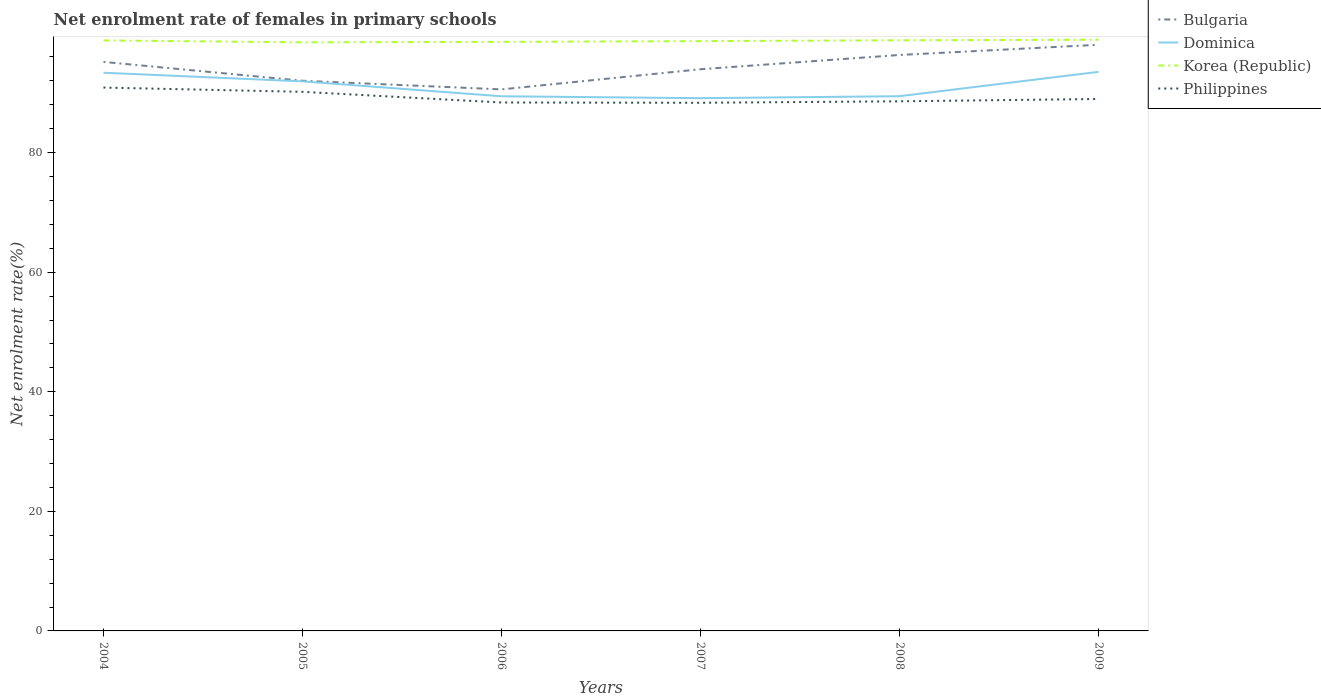Does the line corresponding to Philippines intersect with the line corresponding to Dominica?
Your answer should be compact. No. Is the number of lines equal to the number of legend labels?
Your answer should be very brief. Yes. Across all years, what is the maximum net enrolment rate of females in primary schools in Dominica?
Your answer should be very brief. 89.1. In which year was the net enrolment rate of females in primary schools in Bulgaria maximum?
Provide a short and direct response. 2006. What is the total net enrolment rate of females in primary schools in Philippines in the graph?
Ensure brevity in your answer.  -0.39. What is the difference between the highest and the second highest net enrolment rate of females in primary schools in Korea (Republic)?
Provide a short and direct response. 0.43. What is the difference between the highest and the lowest net enrolment rate of females in primary schools in Philippines?
Provide a short and direct response. 2. How many lines are there?
Ensure brevity in your answer.  4. Does the graph contain any zero values?
Your answer should be compact. No. How many legend labels are there?
Make the answer very short. 4. What is the title of the graph?
Provide a succinct answer. Net enrolment rate of females in primary schools. What is the label or title of the Y-axis?
Your answer should be compact. Net enrolment rate(%). What is the Net enrolment rate(%) in Bulgaria in 2004?
Your answer should be compact. 95.17. What is the Net enrolment rate(%) in Dominica in 2004?
Make the answer very short. 93.36. What is the Net enrolment rate(%) of Korea (Republic) in 2004?
Your answer should be compact. 98.76. What is the Net enrolment rate(%) in Philippines in 2004?
Offer a very short reply. 90.88. What is the Net enrolment rate(%) in Bulgaria in 2005?
Give a very brief answer. 92.02. What is the Net enrolment rate(%) of Dominica in 2005?
Your response must be concise. 91.91. What is the Net enrolment rate(%) of Korea (Republic) in 2005?
Offer a terse response. 98.45. What is the Net enrolment rate(%) in Philippines in 2005?
Ensure brevity in your answer.  90.16. What is the Net enrolment rate(%) of Bulgaria in 2006?
Provide a short and direct response. 90.57. What is the Net enrolment rate(%) in Dominica in 2006?
Make the answer very short. 89.42. What is the Net enrolment rate(%) of Korea (Republic) in 2006?
Give a very brief answer. 98.52. What is the Net enrolment rate(%) of Philippines in 2006?
Provide a succinct answer. 88.38. What is the Net enrolment rate(%) in Bulgaria in 2007?
Keep it short and to the point. 93.94. What is the Net enrolment rate(%) of Dominica in 2007?
Keep it short and to the point. 89.1. What is the Net enrolment rate(%) in Korea (Republic) in 2007?
Give a very brief answer. 98.64. What is the Net enrolment rate(%) in Philippines in 2007?
Your answer should be compact. 88.33. What is the Net enrolment rate(%) of Bulgaria in 2008?
Offer a very short reply. 96.33. What is the Net enrolment rate(%) of Dominica in 2008?
Your answer should be very brief. 89.43. What is the Net enrolment rate(%) of Korea (Republic) in 2008?
Your answer should be compact. 98.79. What is the Net enrolment rate(%) in Philippines in 2008?
Your response must be concise. 88.58. What is the Net enrolment rate(%) in Bulgaria in 2009?
Give a very brief answer. 98.04. What is the Net enrolment rate(%) of Dominica in 2009?
Offer a very short reply. 93.5. What is the Net enrolment rate(%) in Korea (Republic) in 2009?
Offer a terse response. 98.88. What is the Net enrolment rate(%) in Philippines in 2009?
Offer a terse response. 88.97. Across all years, what is the maximum Net enrolment rate(%) of Bulgaria?
Provide a succinct answer. 98.04. Across all years, what is the maximum Net enrolment rate(%) of Dominica?
Offer a very short reply. 93.5. Across all years, what is the maximum Net enrolment rate(%) in Korea (Republic)?
Provide a short and direct response. 98.88. Across all years, what is the maximum Net enrolment rate(%) of Philippines?
Offer a very short reply. 90.88. Across all years, what is the minimum Net enrolment rate(%) in Bulgaria?
Keep it short and to the point. 90.57. Across all years, what is the minimum Net enrolment rate(%) in Dominica?
Provide a succinct answer. 89.1. Across all years, what is the minimum Net enrolment rate(%) of Korea (Republic)?
Offer a very short reply. 98.45. Across all years, what is the minimum Net enrolment rate(%) in Philippines?
Your answer should be compact. 88.33. What is the total Net enrolment rate(%) in Bulgaria in the graph?
Give a very brief answer. 566.06. What is the total Net enrolment rate(%) of Dominica in the graph?
Offer a very short reply. 546.73. What is the total Net enrolment rate(%) of Korea (Republic) in the graph?
Give a very brief answer. 592.03. What is the total Net enrolment rate(%) in Philippines in the graph?
Make the answer very short. 535.3. What is the difference between the Net enrolment rate(%) in Bulgaria in 2004 and that in 2005?
Your answer should be very brief. 3.15. What is the difference between the Net enrolment rate(%) in Dominica in 2004 and that in 2005?
Your answer should be very brief. 1.45. What is the difference between the Net enrolment rate(%) in Korea (Republic) in 2004 and that in 2005?
Give a very brief answer. 0.32. What is the difference between the Net enrolment rate(%) of Philippines in 2004 and that in 2005?
Your response must be concise. 0.71. What is the difference between the Net enrolment rate(%) of Bulgaria in 2004 and that in 2006?
Your answer should be compact. 4.6. What is the difference between the Net enrolment rate(%) of Dominica in 2004 and that in 2006?
Give a very brief answer. 3.94. What is the difference between the Net enrolment rate(%) in Korea (Republic) in 2004 and that in 2006?
Your response must be concise. 0.24. What is the difference between the Net enrolment rate(%) in Philippines in 2004 and that in 2006?
Offer a very short reply. 2.5. What is the difference between the Net enrolment rate(%) in Bulgaria in 2004 and that in 2007?
Give a very brief answer. 1.23. What is the difference between the Net enrolment rate(%) in Dominica in 2004 and that in 2007?
Offer a terse response. 4.26. What is the difference between the Net enrolment rate(%) of Korea (Republic) in 2004 and that in 2007?
Provide a succinct answer. 0.12. What is the difference between the Net enrolment rate(%) in Philippines in 2004 and that in 2007?
Keep it short and to the point. 2.54. What is the difference between the Net enrolment rate(%) of Bulgaria in 2004 and that in 2008?
Ensure brevity in your answer.  -1.16. What is the difference between the Net enrolment rate(%) of Dominica in 2004 and that in 2008?
Make the answer very short. 3.93. What is the difference between the Net enrolment rate(%) of Korea (Republic) in 2004 and that in 2008?
Your answer should be very brief. -0.02. What is the difference between the Net enrolment rate(%) of Philippines in 2004 and that in 2008?
Keep it short and to the point. 2.3. What is the difference between the Net enrolment rate(%) of Bulgaria in 2004 and that in 2009?
Provide a succinct answer. -2.87. What is the difference between the Net enrolment rate(%) of Dominica in 2004 and that in 2009?
Your response must be concise. -0.14. What is the difference between the Net enrolment rate(%) in Korea (Republic) in 2004 and that in 2009?
Ensure brevity in your answer.  -0.12. What is the difference between the Net enrolment rate(%) in Philippines in 2004 and that in 2009?
Your answer should be very brief. 1.91. What is the difference between the Net enrolment rate(%) of Bulgaria in 2005 and that in 2006?
Provide a succinct answer. 1.45. What is the difference between the Net enrolment rate(%) of Dominica in 2005 and that in 2006?
Provide a short and direct response. 2.49. What is the difference between the Net enrolment rate(%) of Korea (Republic) in 2005 and that in 2006?
Ensure brevity in your answer.  -0.07. What is the difference between the Net enrolment rate(%) of Philippines in 2005 and that in 2006?
Make the answer very short. 1.78. What is the difference between the Net enrolment rate(%) in Bulgaria in 2005 and that in 2007?
Offer a very short reply. -1.93. What is the difference between the Net enrolment rate(%) in Dominica in 2005 and that in 2007?
Provide a short and direct response. 2.81. What is the difference between the Net enrolment rate(%) of Korea (Republic) in 2005 and that in 2007?
Offer a terse response. -0.2. What is the difference between the Net enrolment rate(%) of Philippines in 2005 and that in 2007?
Your answer should be very brief. 1.83. What is the difference between the Net enrolment rate(%) of Bulgaria in 2005 and that in 2008?
Offer a very short reply. -4.31. What is the difference between the Net enrolment rate(%) in Dominica in 2005 and that in 2008?
Make the answer very short. 2.48. What is the difference between the Net enrolment rate(%) in Korea (Republic) in 2005 and that in 2008?
Ensure brevity in your answer.  -0.34. What is the difference between the Net enrolment rate(%) of Philippines in 2005 and that in 2008?
Keep it short and to the point. 1.59. What is the difference between the Net enrolment rate(%) of Bulgaria in 2005 and that in 2009?
Your answer should be compact. -6.02. What is the difference between the Net enrolment rate(%) of Dominica in 2005 and that in 2009?
Provide a succinct answer. -1.59. What is the difference between the Net enrolment rate(%) of Korea (Republic) in 2005 and that in 2009?
Ensure brevity in your answer.  -0.43. What is the difference between the Net enrolment rate(%) in Philippines in 2005 and that in 2009?
Ensure brevity in your answer.  1.2. What is the difference between the Net enrolment rate(%) of Bulgaria in 2006 and that in 2007?
Offer a very short reply. -3.37. What is the difference between the Net enrolment rate(%) of Dominica in 2006 and that in 2007?
Provide a short and direct response. 0.32. What is the difference between the Net enrolment rate(%) in Korea (Republic) in 2006 and that in 2007?
Provide a succinct answer. -0.13. What is the difference between the Net enrolment rate(%) of Philippines in 2006 and that in 2007?
Your answer should be very brief. 0.05. What is the difference between the Net enrolment rate(%) in Bulgaria in 2006 and that in 2008?
Make the answer very short. -5.76. What is the difference between the Net enrolment rate(%) of Dominica in 2006 and that in 2008?
Provide a short and direct response. -0.01. What is the difference between the Net enrolment rate(%) in Korea (Republic) in 2006 and that in 2008?
Provide a short and direct response. -0.27. What is the difference between the Net enrolment rate(%) of Philippines in 2006 and that in 2008?
Your answer should be compact. -0.2. What is the difference between the Net enrolment rate(%) of Bulgaria in 2006 and that in 2009?
Offer a terse response. -7.46. What is the difference between the Net enrolment rate(%) of Dominica in 2006 and that in 2009?
Ensure brevity in your answer.  -4.08. What is the difference between the Net enrolment rate(%) of Korea (Republic) in 2006 and that in 2009?
Offer a very short reply. -0.36. What is the difference between the Net enrolment rate(%) in Philippines in 2006 and that in 2009?
Give a very brief answer. -0.59. What is the difference between the Net enrolment rate(%) of Bulgaria in 2007 and that in 2008?
Keep it short and to the point. -2.38. What is the difference between the Net enrolment rate(%) in Dominica in 2007 and that in 2008?
Ensure brevity in your answer.  -0.33. What is the difference between the Net enrolment rate(%) of Korea (Republic) in 2007 and that in 2008?
Your answer should be very brief. -0.14. What is the difference between the Net enrolment rate(%) in Philippines in 2007 and that in 2008?
Offer a terse response. -0.25. What is the difference between the Net enrolment rate(%) of Bulgaria in 2007 and that in 2009?
Your response must be concise. -4.09. What is the difference between the Net enrolment rate(%) of Dominica in 2007 and that in 2009?
Offer a terse response. -4.4. What is the difference between the Net enrolment rate(%) in Korea (Republic) in 2007 and that in 2009?
Offer a very short reply. -0.23. What is the difference between the Net enrolment rate(%) in Philippines in 2007 and that in 2009?
Give a very brief answer. -0.63. What is the difference between the Net enrolment rate(%) of Bulgaria in 2008 and that in 2009?
Offer a terse response. -1.71. What is the difference between the Net enrolment rate(%) of Dominica in 2008 and that in 2009?
Your answer should be compact. -4.07. What is the difference between the Net enrolment rate(%) of Korea (Republic) in 2008 and that in 2009?
Offer a terse response. -0.09. What is the difference between the Net enrolment rate(%) of Philippines in 2008 and that in 2009?
Provide a short and direct response. -0.39. What is the difference between the Net enrolment rate(%) of Bulgaria in 2004 and the Net enrolment rate(%) of Dominica in 2005?
Your response must be concise. 3.26. What is the difference between the Net enrolment rate(%) of Bulgaria in 2004 and the Net enrolment rate(%) of Korea (Republic) in 2005?
Give a very brief answer. -3.28. What is the difference between the Net enrolment rate(%) in Bulgaria in 2004 and the Net enrolment rate(%) in Philippines in 2005?
Your response must be concise. 5.01. What is the difference between the Net enrolment rate(%) of Dominica in 2004 and the Net enrolment rate(%) of Korea (Republic) in 2005?
Your answer should be very brief. -5.09. What is the difference between the Net enrolment rate(%) in Dominica in 2004 and the Net enrolment rate(%) in Philippines in 2005?
Offer a terse response. 3.2. What is the difference between the Net enrolment rate(%) of Korea (Republic) in 2004 and the Net enrolment rate(%) of Philippines in 2005?
Make the answer very short. 8.6. What is the difference between the Net enrolment rate(%) of Bulgaria in 2004 and the Net enrolment rate(%) of Dominica in 2006?
Keep it short and to the point. 5.75. What is the difference between the Net enrolment rate(%) of Bulgaria in 2004 and the Net enrolment rate(%) of Korea (Republic) in 2006?
Keep it short and to the point. -3.35. What is the difference between the Net enrolment rate(%) of Bulgaria in 2004 and the Net enrolment rate(%) of Philippines in 2006?
Provide a short and direct response. 6.79. What is the difference between the Net enrolment rate(%) of Dominica in 2004 and the Net enrolment rate(%) of Korea (Republic) in 2006?
Offer a terse response. -5.16. What is the difference between the Net enrolment rate(%) in Dominica in 2004 and the Net enrolment rate(%) in Philippines in 2006?
Provide a short and direct response. 4.98. What is the difference between the Net enrolment rate(%) of Korea (Republic) in 2004 and the Net enrolment rate(%) of Philippines in 2006?
Keep it short and to the point. 10.38. What is the difference between the Net enrolment rate(%) in Bulgaria in 2004 and the Net enrolment rate(%) in Dominica in 2007?
Keep it short and to the point. 6.07. What is the difference between the Net enrolment rate(%) of Bulgaria in 2004 and the Net enrolment rate(%) of Korea (Republic) in 2007?
Give a very brief answer. -3.47. What is the difference between the Net enrolment rate(%) of Bulgaria in 2004 and the Net enrolment rate(%) of Philippines in 2007?
Provide a succinct answer. 6.84. What is the difference between the Net enrolment rate(%) in Dominica in 2004 and the Net enrolment rate(%) in Korea (Republic) in 2007?
Provide a succinct answer. -5.28. What is the difference between the Net enrolment rate(%) of Dominica in 2004 and the Net enrolment rate(%) of Philippines in 2007?
Your response must be concise. 5.03. What is the difference between the Net enrolment rate(%) in Korea (Republic) in 2004 and the Net enrolment rate(%) in Philippines in 2007?
Provide a succinct answer. 10.43. What is the difference between the Net enrolment rate(%) of Bulgaria in 2004 and the Net enrolment rate(%) of Dominica in 2008?
Ensure brevity in your answer.  5.74. What is the difference between the Net enrolment rate(%) in Bulgaria in 2004 and the Net enrolment rate(%) in Korea (Republic) in 2008?
Keep it short and to the point. -3.62. What is the difference between the Net enrolment rate(%) of Bulgaria in 2004 and the Net enrolment rate(%) of Philippines in 2008?
Your response must be concise. 6.59. What is the difference between the Net enrolment rate(%) of Dominica in 2004 and the Net enrolment rate(%) of Korea (Republic) in 2008?
Offer a very short reply. -5.43. What is the difference between the Net enrolment rate(%) in Dominica in 2004 and the Net enrolment rate(%) in Philippines in 2008?
Your answer should be compact. 4.78. What is the difference between the Net enrolment rate(%) in Korea (Republic) in 2004 and the Net enrolment rate(%) in Philippines in 2008?
Your answer should be compact. 10.18. What is the difference between the Net enrolment rate(%) of Bulgaria in 2004 and the Net enrolment rate(%) of Dominica in 2009?
Offer a very short reply. 1.67. What is the difference between the Net enrolment rate(%) of Bulgaria in 2004 and the Net enrolment rate(%) of Korea (Republic) in 2009?
Your response must be concise. -3.71. What is the difference between the Net enrolment rate(%) of Bulgaria in 2004 and the Net enrolment rate(%) of Philippines in 2009?
Offer a very short reply. 6.2. What is the difference between the Net enrolment rate(%) of Dominica in 2004 and the Net enrolment rate(%) of Korea (Republic) in 2009?
Make the answer very short. -5.52. What is the difference between the Net enrolment rate(%) of Dominica in 2004 and the Net enrolment rate(%) of Philippines in 2009?
Your answer should be compact. 4.39. What is the difference between the Net enrolment rate(%) in Korea (Republic) in 2004 and the Net enrolment rate(%) in Philippines in 2009?
Your answer should be compact. 9.79. What is the difference between the Net enrolment rate(%) of Bulgaria in 2005 and the Net enrolment rate(%) of Dominica in 2006?
Give a very brief answer. 2.6. What is the difference between the Net enrolment rate(%) in Bulgaria in 2005 and the Net enrolment rate(%) in Korea (Republic) in 2006?
Provide a short and direct response. -6.5. What is the difference between the Net enrolment rate(%) of Bulgaria in 2005 and the Net enrolment rate(%) of Philippines in 2006?
Offer a very short reply. 3.64. What is the difference between the Net enrolment rate(%) of Dominica in 2005 and the Net enrolment rate(%) of Korea (Republic) in 2006?
Offer a very short reply. -6.61. What is the difference between the Net enrolment rate(%) of Dominica in 2005 and the Net enrolment rate(%) of Philippines in 2006?
Keep it short and to the point. 3.53. What is the difference between the Net enrolment rate(%) of Korea (Republic) in 2005 and the Net enrolment rate(%) of Philippines in 2006?
Ensure brevity in your answer.  10.07. What is the difference between the Net enrolment rate(%) of Bulgaria in 2005 and the Net enrolment rate(%) of Dominica in 2007?
Offer a very short reply. 2.92. What is the difference between the Net enrolment rate(%) of Bulgaria in 2005 and the Net enrolment rate(%) of Korea (Republic) in 2007?
Your answer should be very brief. -6.63. What is the difference between the Net enrolment rate(%) of Bulgaria in 2005 and the Net enrolment rate(%) of Philippines in 2007?
Keep it short and to the point. 3.68. What is the difference between the Net enrolment rate(%) in Dominica in 2005 and the Net enrolment rate(%) in Korea (Republic) in 2007?
Ensure brevity in your answer.  -6.73. What is the difference between the Net enrolment rate(%) in Dominica in 2005 and the Net enrolment rate(%) in Philippines in 2007?
Provide a short and direct response. 3.58. What is the difference between the Net enrolment rate(%) in Korea (Republic) in 2005 and the Net enrolment rate(%) in Philippines in 2007?
Provide a succinct answer. 10.11. What is the difference between the Net enrolment rate(%) in Bulgaria in 2005 and the Net enrolment rate(%) in Dominica in 2008?
Offer a very short reply. 2.58. What is the difference between the Net enrolment rate(%) in Bulgaria in 2005 and the Net enrolment rate(%) in Korea (Republic) in 2008?
Give a very brief answer. -6.77. What is the difference between the Net enrolment rate(%) of Bulgaria in 2005 and the Net enrolment rate(%) of Philippines in 2008?
Offer a very short reply. 3.44. What is the difference between the Net enrolment rate(%) in Dominica in 2005 and the Net enrolment rate(%) in Korea (Republic) in 2008?
Ensure brevity in your answer.  -6.88. What is the difference between the Net enrolment rate(%) of Dominica in 2005 and the Net enrolment rate(%) of Philippines in 2008?
Offer a terse response. 3.33. What is the difference between the Net enrolment rate(%) of Korea (Republic) in 2005 and the Net enrolment rate(%) of Philippines in 2008?
Make the answer very short. 9.87. What is the difference between the Net enrolment rate(%) in Bulgaria in 2005 and the Net enrolment rate(%) in Dominica in 2009?
Make the answer very short. -1.49. What is the difference between the Net enrolment rate(%) in Bulgaria in 2005 and the Net enrolment rate(%) in Korea (Republic) in 2009?
Your answer should be compact. -6.86. What is the difference between the Net enrolment rate(%) of Bulgaria in 2005 and the Net enrolment rate(%) of Philippines in 2009?
Your answer should be compact. 3.05. What is the difference between the Net enrolment rate(%) of Dominica in 2005 and the Net enrolment rate(%) of Korea (Republic) in 2009?
Provide a short and direct response. -6.97. What is the difference between the Net enrolment rate(%) in Dominica in 2005 and the Net enrolment rate(%) in Philippines in 2009?
Provide a succinct answer. 2.94. What is the difference between the Net enrolment rate(%) in Korea (Republic) in 2005 and the Net enrolment rate(%) in Philippines in 2009?
Ensure brevity in your answer.  9.48. What is the difference between the Net enrolment rate(%) in Bulgaria in 2006 and the Net enrolment rate(%) in Dominica in 2007?
Give a very brief answer. 1.47. What is the difference between the Net enrolment rate(%) of Bulgaria in 2006 and the Net enrolment rate(%) of Korea (Republic) in 2007?
Your answer should be compact. -8.07. What is the difference between the Net enrolment rate(%) of Bulgaria in 2006 and the Net enrolment rate(%) of Philippines in 2007?
Provide a short and direct response. 2.24. What is the difference between the Net enrolment rate(%) in Dominica in 2006 and the Net enrolment rate(%) in Korea (Republic) in 2007?
Your answer should be very brief. -9.22. What is the difference between the Net enrolment rate(%) in Dominica in 2006 and the Net enrolment rate(%) in Philippines in 2007?
Keep it short and to the point. 1.09. What is the difference between the Net enrolment rate(%) of Korea (Republic) in 2006 and the Net enrolment rate(%) of Philippines in 2007?
Make the answer very short. 10.19. What is the difference between the Net enrolment rate(%) of Bulgaria in 2006 and the Net enrolment rate(%) of Dominica in 2008?
Keep it short and to the point. 1.14. What is the difference between the Net enrolment rate(%) in Bulgaria in 2006 and the Net enrolment rate(%) in Korea (Republic) in 2008?
Your answer should be compact. -8.21. What is the difference between the Net enrolment rate(%) in Bulgaria in 2006 and the Net enrolment rate(%) in Philippines in 2008?
Provide a succinct answer. 1.99. What is the difference between the Net enrolment rate(%) in Dominica in 2006 and the Net enrolment rate(%) in Korea (Republic) in 2008?
Provide a succinct answer. -9.36. What is the difference between the Net enrolment rate(%) in Dominica in 2006 and the Net enrolment rate(%) in Philippines in 2008?
Offer a very short reply. 0.84. What is the difference between the Net enrolment rate(%) in Korea (Republic) in 2006 and the Net enrolment rate(%) in Philippines in 2008?
Offer a terse response. 9.94. What is the difference between the Net enrolment rate(%) of Bulgaria in 2006 and the Net enrolment rate(%) of Dominica in 2009?
Give a very brief answer. -2.93. What is the difference between the Net enrolment rate(%) of Bulgaria in 2006 and the Net enrolment rate(%) of Korea (Republic) in 2009?
Make the answer very short. -8.31. What is the difference between the Net enrolment rate(%) in Bulgaria in 2006 and the Net enrolment rate(%) in Philippines in 2009?
Your answer should be very brief. 1.61. What is the difference between the Net enrolment rate(%) of Dominica in 2006 and the Net enrolment rate(%) of Korea (Republic) in 2009?
Offer a very short reply. -9.46. What is the difference between the Net enrolment rate(%) in Dominica in 2006 and the Net enrolment rate(%) in Philippines in 2009?
Your answer should be very brief. 0.45. What is the difference between the Net enrolment rate(%) in Korea (Republic) in 2006 and the Net enrolment rate(%) in Philippines in 2009?
Your answer should be compact. 9.55. What is the difference between the Net enrolment rate(%) of Bulgaria in 2007 and the Net enrolment rate(%) of Dominica in 2008?
Your response must be concise. 4.51. What is the difference between the Net enrolment rate(%) in Bulgaria in 2007 and the Net enrolment rate(%) in Korea (Republic) in 2008?
Your answer should be very brief. -4.84. What is the difference between the Net enrolment rate(%) in Bulgaria in 2007 and the Net enrolment rate(%) in Philippines in 2008?
Ensure brevity in your answer.  5.37. What is the difference between the Net enrolment rate(%) of Dominica in 2007 and the Net enrolment rate(%) of Korea (Republic) in 2008?
Your response must be concise. -9.68. What is the difference between the Net enrolment rate(%) in Dominica in 2007 and the Net enrolment rate(%) in Philippines in 2008?
Your response must be concise. 0.52. What is the difference between the Net enrolment rate(%) in Korea (Republic) in 2007 and the Net enrolment rate(%) in Philippines in 2008?
Provide a succinct answer. 10.07. What is the difference between the Net enrolment rate(%) in Bulgaria in 2007 and the Net enrolment rate(%) in Dominica in 2009?
Your response must be concise. 0.44. What is the difference between the Net enrolment rate(%) of Bulgaria in 2007 and the Net enrolment rate(%) of Korea (Republic) in 2009?
Your answer should be compact. -4.93. What is the difference between the Net enrolment rate(%) in Bulgaria in 2007 and the Net enrolment rate(%) in Philippines in 2009?
Provide a short and direct response. 4.98. What is the difference between the Net enrolment rate(%) of Dominica in 2007 and the Net enrolment rate(%) of Korea (Republic) in 2009?
Keep it short and to the point. -9.78. What is the difference between the Net enrolment rate(%) of Dominica in 2007 and the Net enrolment rate(%) of Philippines in 2009?
Give a very brief answer. 0.14. What is the difference between the Net enrolment rate(%) of Korea (Republic) in 2007 and the Net enrolment rate(%) of Philippines in 2009?
Your answer should be very brief. 9.68. What is the difference between the Net enrolment rate(%) of Bulgaria in 2008 and the Net enrolment rate(%) of Dominica in 2009?
Your response must be concise. 2.82. What is the difference between the Net enrolment rate(%) of Bulgaria in 2008 and the Net enrolment rate(%) of Korea (Republic) in 2009?
Offer a terse response. -2.55. What is the difference between the Net enrolment rate(%) in Bulgaria in 2008 and the Net enrolment rate(%) in Philippines in 2009?
Give a very brief answer. 7.36. What is the difference between the Net enrolment rate(%) of Dominica in 2008 and the Net enrolment rate(%) of Korea (Republic) in 2009?
Ensure brevity in your answer.  -9.44. What is the difference between the Net enrolment rate(%) in Dominica in 2008 and the Net enrolment rate(%) in Philippines in 2009?
Your answer should be compact. 0.47. What is the difference between the Net enrolment rate(%) of Korea (Republic) in 2008 and the Net enrolment rate(%) of Philippines in 2009?
Provide a succinct answer. 9.82. What is the average Net enrolment rate(%) in Bulgaria per year?
Provide a short and direct response. 94.34. What is the average Net enrolment rate(%) in Dominica per year?
Make the answer very short. 91.12. What is the average Net enrolment rate(%) in Korea (Republic) per year?
Provide a short and direct response. 98.67. What is the average Net enrolment rate(%) of Philippines per year?
Ensure brevity in your answer.  89.22. In the year 2004, what is the difference between the Net enrolment rate(%) in Bulgaria and Net enrolment rate(%) in Dominica?
Give a very brief answer. 1.81. In the year 2004, what is the difference between the Net enrolment rate(%) in Bulgaria and Net enrolment rate(%) in Korea (Republic)?
Offer a very short reply. -3.59. In the year 2004, what is the difference between the Net enrolment rate(%) of Bulgaria and Net enrolment rate(%) of Philippines?
Keep it short and to the point. 4.29. In the year 2004, what is the difference between the Net enrolment rate(%) of Dominica and Net enrolment rate(%) of Korea (Republic)?
Give a very brief answer. -5.4. In the year 2004, what is the difference between the Net enrolment rate(%) of Dominica and Net enrolment rate(%) of Philippines?
Provide a short and direct response. 2.48. In the year 2004, what is the difference between the Net enrolment rate(%) in Korea (Republic) and Net enrolment rate(%) in Philippines?
Ensure brevity in your answer.  7.88. In the year 2005, what is the difference between the Net enrolment rate(%) in Bulgaria and Net enrolment rate(%) in Dominica?
Keep it short and to the point. 0.11. In the year 2005, what is the difference between the Net enrolment rate(%) of Bulgaria and Net enrolment rate(%) of Korea (Republic)?
Ensure brevity in your answer.  -6.43. In the year 2005, what is the difference between the Net enrolment rate(%) of Bulgaria and Net enrolment rate(%) of Philippines?
Your response must be concise. 1.85. In the year 2005, what is the difference between the Net enrolment rate(%) of Dominica and Net enrolment rate(%) of Korea (Republic)?
Provide a succinct answer. -6.54. In the year 2005, what is the difference between the Net enrolment rate(%) in Dominica and Net enrolment rate(%) in Philippines?
Give a very brief answer. 1.75. In the year 2005, what is the difference between the Net enrolment rate(%) in Korea (Republic) and Net enrolment rate(%) in Philippines?
Ensure brevity in your answer.  8.28. In the year 2006, what is the difference between the Net enrolment rate(%) in Bulgaria and Net enrolment rate(%) in Dominica?
Offer a very short reply. 1.15. In the year 2006, what is the difference between the Net enrolment rate(%) in Bulgaria and Net enrolment rate(%) in Korea (Republic)?
Provide a succinct answer. -7.95. In the year 2006, what is the difference between the Net enrolment rate(%) in Bulgaria and Net enrolment rate(%) in Philippines?
Give a very brief answer. 2.19. In the year 2006, what is the difference between the Net enrolment rate(%) of Dominica and Net enrolment rate(%) of Korea (Republic)?
Your response must be concise. -9.1. In the year 2006, what is the difference between the Net enrolment rate(%) in Dominica and Net enrolment rate(%) in Philippines?
Make the answer very short. 1.04. In the year 2006, what is the difference between the Net enrolment rate(%) in Korea (Republic) and Net enrolment rate(%) in Philippines?
Provide a short and direct response. 10.14. In the year 2007, what is the difference between the Net enrolment rate(%) in Bulgaria and Net enrolment rate(%) in Dominica?
Provide a short and direct response. 4.84. In the year 2007, what is the difference between the Net enrolment rate(%) of Bulgaria and Net enrolment rate(%) of Korea (Republic)?
Ensure brevity in your answer.  -4.7. In the year 2007, what is the difference between the Net enrolment rate(%) of Bulgaria and Net enrolment rate(%) of Philippines?
Your answer should be very brief. 5.61. In the year 2007, what is the difference between the Net enrolment rate(%) of Dominica and Net enrolment rate(%) of Korea (Republic)?
Your answer should be very brief. -9.54. In the year 2007, what is the difference between the Net enrolment rate(%) of Dominica and Net enrolment rate(%) of Philippines?
Offer a very short reply. 0.77. In the year 2007, what is the difference between the Net enrolment rate(%) of Korea (Republic) and Net enrolment rate(%) of Philippines?
Your response must be concise. 10.31. In the year 2008, what is the difference between the Net enrolment rate(%) in Bulgaria and Net enrolment rate(%) in Dominica?
Give a very brief answer. 6.89. In the year 2008, what is the difference between the Net enrolment rate(%) in Bulgaria and Net enrolment rate(%) in Korea (Republic)?
Provide a short and direct response. -2.46. In the year 2008, what is the difference between the Net enrolment rate(%) of Bulgaria and Net enrolment rate(%) of Philippines?
Your answer should be compact. 7.75. In the year 2008, what is the difference between the Net enrolment rate(%) of Dominica and Net enrolment rate(%) of Korea (Republic)?
Provide a succinct answer. -9.35. In the year 2008, what is the difference between the Net enrolment rate(%) in Dominica and Net enrolment rate(%) in Philippines?
Ensure brevity in your answer.  0.85. In the year 2008, what is the difference between the Net enrolment rate(%) of Korea (Republic) and Net enrolment rate(%) of Philippines?
Your answer should be compact. 10.21. In the year 2009, what is the difference between the Net enrolment rate(%) in Bulgaria and Net enrolment rate(%) in Dominica?
Your response must be concise. 4.53. In the year 2009, what is the difference between the Net enrolment rate(%) of Bulgaria and Net enrolment rate(%) of Korea (Republic)?
Give a very brief answer. -0.84. In the year 2009, what is the difference between the Net enrolment rate(%) of Bulgaria and Net enrolment rate(%) of Philippines?
Ensure brevity in your answer.  9.07. In the year 2009, what is the difference between the Net enrolment rate(%) in Dominica and Net enrolment rate(%) in Korea (Republic)?
Offer a terse response. -5.37. In the year 2009, what is the difference between the Net enrolment rate(%) of Dominica and Net enrolment rate(%) of Philippines?
Your answer should be very brief. 4.54. In the year 2009, what is the difference between the Net enrolment rate(%) of Korea (Republic) and Net enrolment rate(%) of Philippines?
Give a very brief answer. 9.91. What is the ratio of the Net enrolment rate(%) of Bulgaria in 2004 to that in 2005?
Offer a very short reply. 1.03. What is the ratio of the Net enrolment rate(%) of Dominica in 2004 to that in 2005?
Give a very brief answer. 1.02. What is the ratio of the Net enrolment rate(%) in Philippines in 2004 to that in 2005?
Keep it short and to the point. 1.01. What is the ratio of the Net enrolment rate(%) in Bulgaria in 2004 to that in 2006?
Your answer should be very brief. 1.05. What is the ratio of the Net enrolment rate(%) in Dominica in 2004 to that in 2006?
Provide a succinct answer. 1.04. What is the ratio of the Net enrolment rate(%) in Philippines in 2004 to that in 2006?
Offer a very short reply. 1.03. What is the ratio of the Net enrolment rate(%) of Bulgaria in 2004 to that in 2007?
Provide a succinct answer. 1.01. What is the ratio of the Net enrolment rate(%) of Dominica in 2004 to that in 2007?
Keep it short and to the point. 1.05. What is the ratio of the Net enrolment rate(%) in Korea (Republic) in 2004 to that in 2007?
Provide a short and direct response. 1. What is the ratio of the Net enrolment rate(%) in Philippines in 2004 to that in 2007?
Ensure brevity in your answer.  1.03. What is the ratio of the Net enrolment rate(%) of Dominica in 2004 to that in 2008?
Your response must be concise. 1.04. What is the ratio of the Net enrolment rate(%) in Bulgaria in 2004 to that in 2009?
Keep it short and to the point. 0.97. What is the ratio of the Net enrolment rate(%) in Korea (Republic) in 2004 to that in 2009?
Offer a very short reply. 1. What is the ratio of the Net enrolment rate(%) of Philippines in 2004 to that in 2009?
Provide a succinct answer. 1.02. What is the ratio of the Net enrolment rate(%) of Bulgaria in 2005 to that in 2006?
Your response must be concise. 1.02. What is the ratio of the Net enrolment rate(%) of Dominica in 2005 to that in 2006?
Your answer should be compact. 1.03. What is the ratio of the Net enrolment rate(%) in Korea (Republic) in 2005 to that in 2006?
Your answer should be very brief. 1. What is the ratio of the Net enrolment rate(%) in Philippines in 2005 to that in 2006?
Make the answer very short. 1.02. What is the ratio of the Net enrolment rate(%) of Bulgaria in 2005 to that in 2007?
Offer a very short reply. 0.98. What is the ratio of the Net enrolment rate(%) in Dominica in 2005 to that in 2007?
Provide a succinct answer. 1.03. What is the ratio of the Net enrolment rate(%) in Philippines in 2005 to that in 2007?
Offer a terse response. 1.02. What is the ratio of the Net enrolment rate(%) of Bulgaria in 2005 to that in 2008?
Provide a short and direct response. 0.96. What is the ratio of the Net enrolment rate(%) in Dominica in 2005 to that in 2008?
Your answer should be very brief. 1.03. What is the ratio of the Net enrolment rate(%) in Korea (Republic) in 2005 to that in 2008?
Give a very brief answer. 1. What is the ratio of the Net enrolment rate(%) of Philippines in 2005 to that in 2008?
Your answer should be very brief. 1.02. What is the ratio of the Net enrolment rate(%) in Bulgaria in 2005 to that in 2009?
Make the answer very short. 0.94. What is the ratio of the Net enrolment rate(%) in Dominica in 2005 to that in 2009?
Provide a succinct answer. 0.98. What is the ratio of the Net enrolment rate(%) of Philippines in 2005 to that in 2009?
Your response must be concise. 1.01. What is the ratio of the Net enrolment rate(%) of Bulgaria in 2006 to that in 2007?
Offer a very short reply. 0.96. What is the ratio of the Net enrolment rate(%) in Dominica in 2006 to that in 2007?
Keep it short and to the point. 1. What is the ratio of the Net enrolment rate(%) of Korea (Republic) in 2006 to that in 2007?
Keep it short and to the point. 1. What is the ratio of the Net enrolment rate(%) of Philippines in 2006 to that in 2007?
Offer a very short reply. 1. What is the ratio of the Net enrolment rate(%) of Bulgaria in 2006 to that in 2008?
Your answer should be very brief. 0.94. What is the ratio of the Net enrolment rate(%) in Philippines in 2006 to that in 2008?
Give a very brief answer. 1. What is the ratio of the Net enrolment rate(%) in Bulgaria in 2006 to that in 2009?
Provide a short and direct response. 0.92. What is the ratio of the Net enrolment rate(%) of Dominica in 2006 to that in 2009?
Offer a very short reply. 0.96. What is the ratio of the Net enrolment rate(%) in Bulgaria in 2007 to that in 2008?
Your answer should be compact. 0.98. What is the ratio of the Net enrolment rate(%) in Korea (Republic) in 2007 to that in 2008?
Your answer should be compact. 1. What is the ratio of the Net enrolment rate(%) in Philippines in 2007 to that in 2008?
Provide a short and direct response. 1. What is the ratio of the Net enrolment rate(%) of Dominica in 2007 to that in 2009?
Give a very brief answer. 0.95. What is the ratio of the Net enrolment rate(%) in Korea (Republic) in 2007 to that in 2009?
Keep it short and to the point. 1. What is the ratio of the Net enrolment rate(%) of Bulgaria in 2008 to that in 2009?
Make the answer very short. 0.98. What is the ratio of the Net enrolment rate(%) in Dominica in 2008 to that in 2009?
Your response must be concise. 0.96. What is the ratio of the Net enrolment rate(%) of Korea (Republic) in 2008 to that in 2009?
Your response must be concise. 1. What is the difference between the highest and the second highest Net enrolment rate(%) of Bulgaria?
Ensure brevity in your answer.  1.71. What is the difference between the highest and the second highest Net enrolment rate(%) in Dominica?
Give a very brief answer. 0.14. What is the difference between the highest and the second highest Net enrolment rate(%) in Korea (Republic)?
Your answer should be compact. 0.09. What is the difference between the highest and the second highest Net enrolment rate(%) in Philippines?
Provide a succinct answer. 0.71. What is the difference between the highest and the lowest Net enrolment rate(%) in Bulgaria?
Offer a very short reply. 7.46. What is the difference between the highest and the lowest Net enrolment rate(%) of Dominica?
Ensure brevity in your answer.  4.4. What is the difference between the highest and the lowest Net enrolment rate(%) of Korea (Republic)?
Provide a succinct answer. 0.43. What is the difference between the highest and the lowest Net enrolment rate(%) in Philippines?
Offer a terse response. 2.54. 